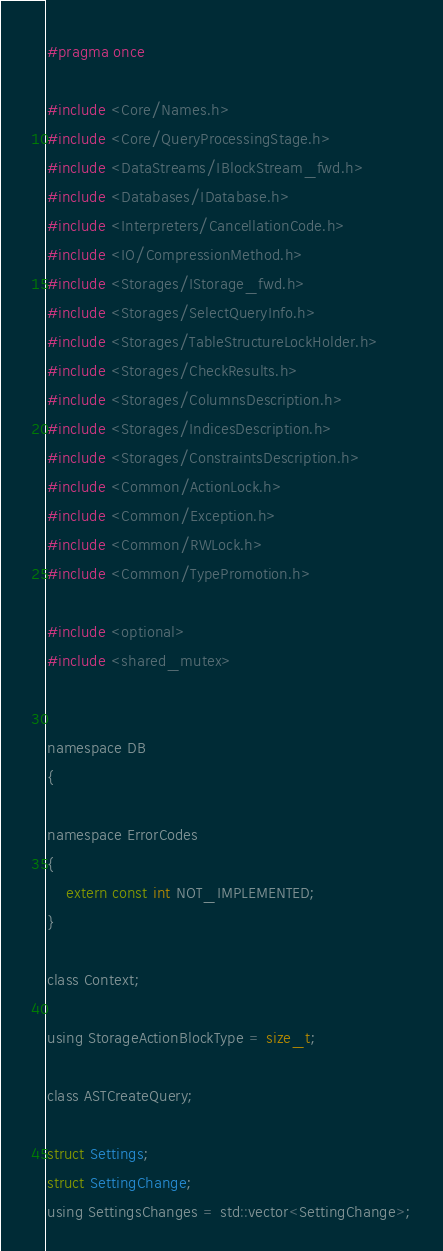Convert code to text. <code><loc_0><loc_0><loc_500><loc_500><_C_>#pragma once

#include <Core/Names.h>
#include <Core/QueryProcessingStage.h>
#include <DataStreams/IBlockStream_fwd.h>
#include <Databases/IDatabase.h>
#include <Interpreters/CancellationCode.h>
#include <IO/CompressionMethod.h>
#include <Storages/IStorage_fwd.h>
#include <Storages/SelectQueryInfo.h>
#include <Storages/TableStructureLockHolder.h>
#include <Storages/CheckResults.h>
#include <Storages/ColumnsDescription.h>
#include <Storages/IndicesDescription.h>
#include <Storages/ConstraintsDescription.h>
#include <Common/ActionLock.h>
#include <Common/Exception.h>
#include <Common/RWLock.h>
#include <Common/TypePromotion.h>

#include <optional>
#include <shared_mutex>


namespace DB
{

namespace ErrorCodes
{
    extern const int NOT_IMPLEMENTED;
}

class Context;

using StorageActionBlockType = size_t;

class ASTCreateQuery;

struct Settings;
struct SettingChange;
using SettingsChanges = std::vector<SettingChange>;
</code> 